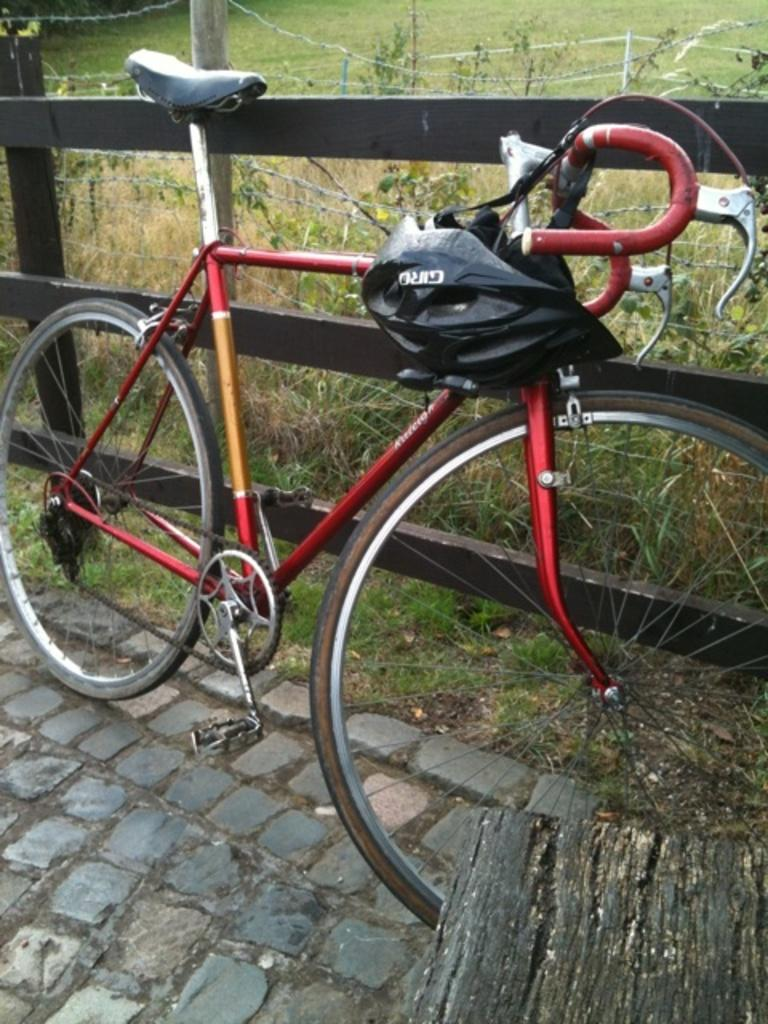What is the main object in the center of the image? There is a cycle in the center of the image. What safety gear is visible in the image? There is a helmet in the image. What can be seen in the background of the image? There is a fence, grass, and plants in the background of the image. What type of government is depicted in the image? There is no depiction of a government in the image; it features a cycle, a helmet, and a background with a fence, grass, and plants. Can you see any fangs in the image? There are no fangs present in the image. 